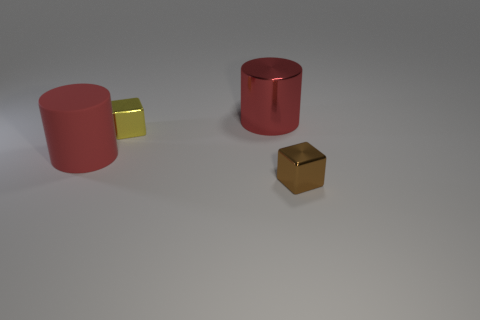What material is the tiny yellow block?
Give a very brief answer. Metal. What color is the thing that is in front of the yellow block and to the left of the shiny cylinder?
Keep it short and to the point. Red. Are there the same number of large things that are in front of the big matte object and large things that are in front of the big metallic thing?
Offer a very short reply. No. There is another tiny object that is made of the same material as the yellow object; what color is it?
Ensure brevity in your answer.  Brown. There is a large matte thing; does it have the same color as the large object that is on the right side of the large rubber thing?
Offer a very short reply. Yes. There is a red cylinder in front of the big red cylinder that is to the right of the matte object; is there a large red cylinder that is on the right side of it?
Keep it short and to the point. Yes. What shape is the small yellow thing that is made of the same material as the brown object?
Offer a very short reply. Cube. There is a tiny yellow shiny thing; what shape is it?
Keep it short and to the point. Cube. Is the shape of the small metallic object that is behind the brown metallic object the same as  the brown metallic thing?
Provide a short and direct response. Yes. Is the number of tiny yellow objects that are in front of the large metallic object greater than the number of large rubber objects to the right of the big red matte object?
Give a very brief answer. Yes. 